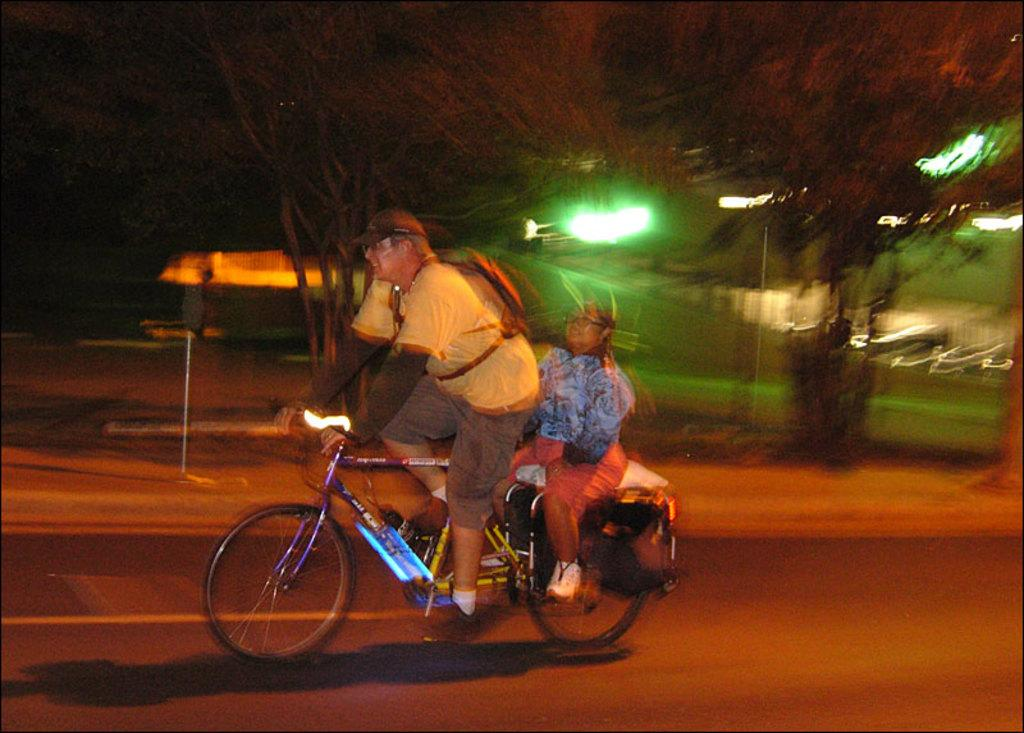What is the man in the image doing? The man is riding a bicycle in the image. Who is with the man on the bicycle? There is a girl sitting behind the man on the bicycle. What can be seen in the background of the image? Trees are visible in the image. What time does the clock in the image show? There is no clock present in the image. What type of bird can be seen sitting on the handlebars of the bicycle? There is no bird, specifically an owl, present in the image. 